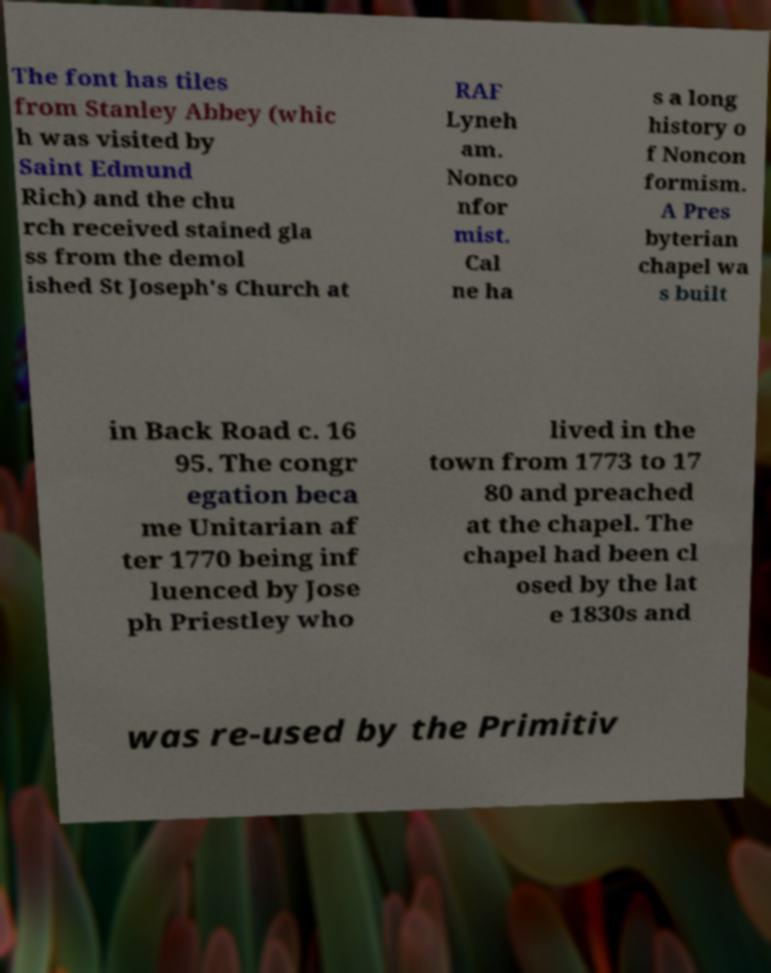Please identify and transcribe the text found in this image. The font has tiles from Stanley Abbey (whic h was visited by Saint Edmund Rich) and the chu rch received stained gla ss from the demol ished St Joseph's Church at RAF Lyneh am. Nonco nfor mist. Cal ne ha s a long history o f Noncon formism. A Pres byterian chapel wa s built in Back Road c. 16 95. The congr egation beca me Unitarian af ter 1770 being inf luenced by Jose ph Priestley who lived in the town from 1773 to 17 80 and preached at the chapel. The chapel had been cl osed by the lat e 1830s and was re-used by the Primitiv 